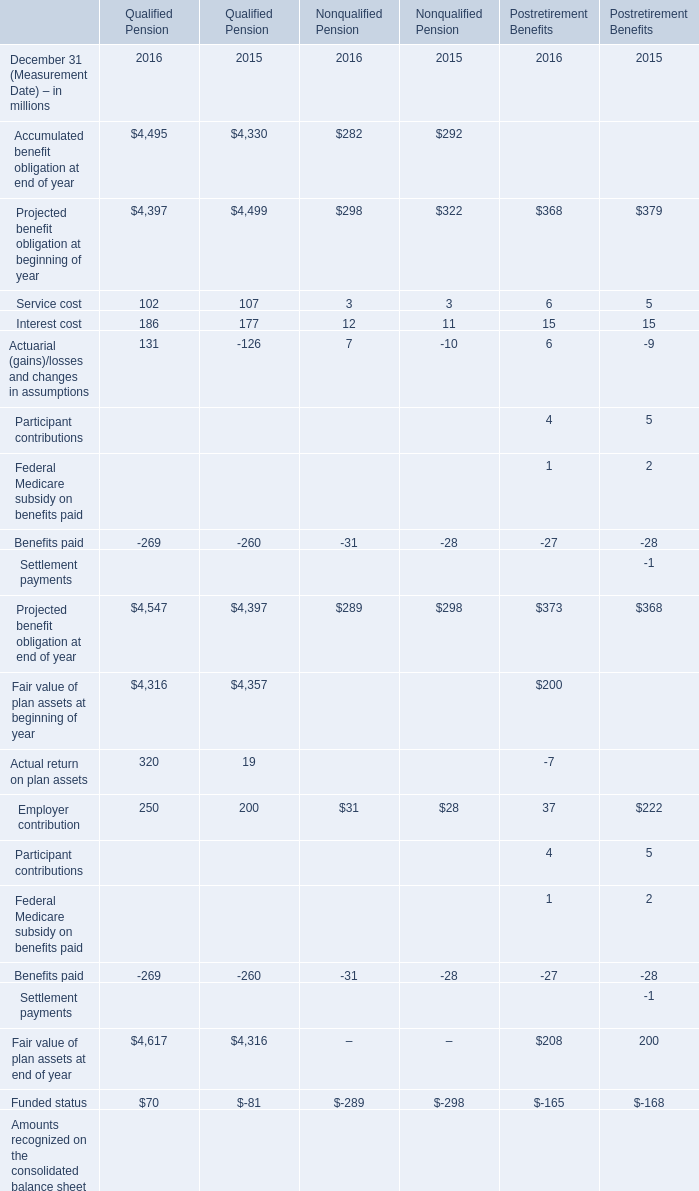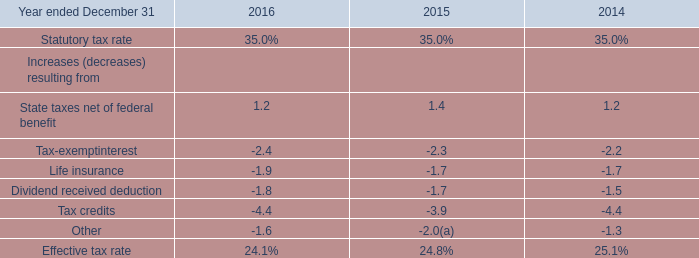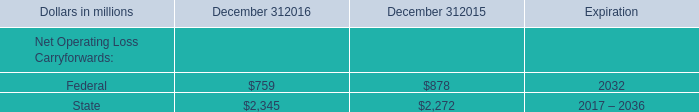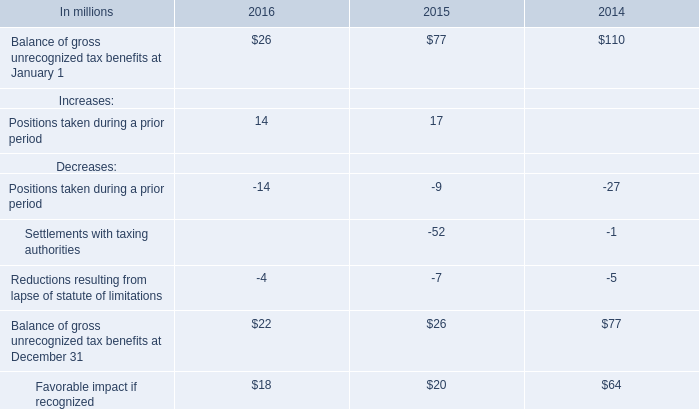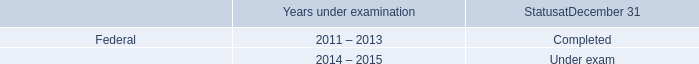In the year with higher Projected benefit obligation at end of year for Nonqualified Pension on December 31, what's the Interest cost for Nonqualified Pensionon on December 31? (in million) 
Answer: 11. 